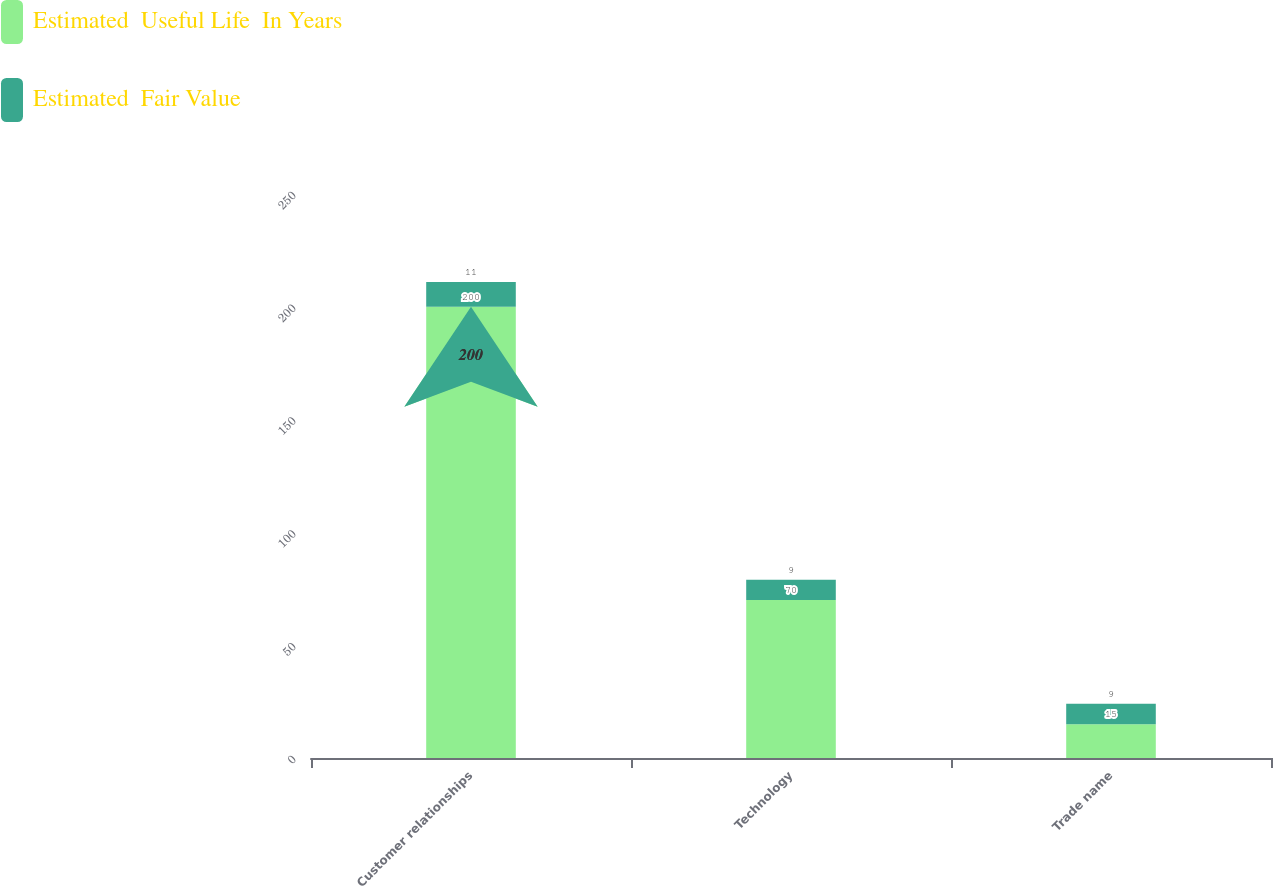Convert chart to OTSL. <chart><loc_0><loc_0><loc_500><loc_500><stacked_bar_chart><ecel><fcel>Customer relationships<fcel>Technology<fcel>Trade name<nl><fcel>Estimated  Useful Life  In Years<fcel>200<fcel>70<fcel>15<nl><fcel>Estimated  Fair Value<fcel>11<fcel>9<fcel>9<nl></chart> 